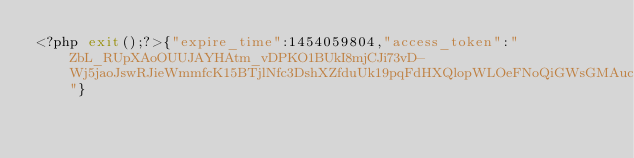<code> <loc_0><loc_0><loc_500><loc_500><_PHP_><?php exit();?>{"expire_time":1454059804,"access_token":"ZbL_RUpXAoOUUJAYHAtm_vDPKO1BUkI8mjCJi73vD-Wj5jaoJswRJieWmmfcK15BTjlNfc3DshXZfduUk19pqFdHXQlopWLOeFNoQiGWsGMAuc_0cMROPY8ccC8r5Rr2WLSdABANCJ"}</code> 